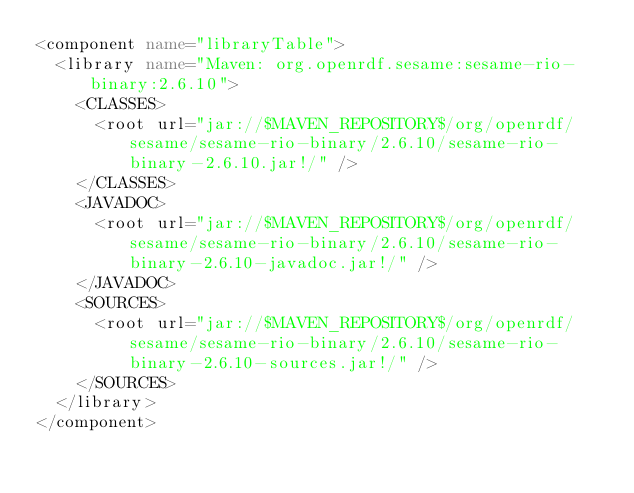Convert code to text. <code><loc_0><loc_0><loc_500><loc_500><_XML_><component name="libraryTable">
  <library name="Maven: org.openrdf.sesame:sesame-rio-binary:2.6.10">
    <CLASSES>
      <root url="jar://$MAVEN_REPOSITORY$/org/openrdf/sesame/sesame-rio-binary/2.6.10/sesame-rio-binary-2.6.10.jar!/" />
    </CLASSES>
    <JAVADOC>
      <root url="jar://$MAVEN_REPOSITORY$/org/openrdf/sesame/sesame-rio-binary/2.6.10/sesame-rio-binary-2.6.10-javadoc.jar!/" />
    </JAVADOC>
    <SOURCES>
      <root url="jar://$MAVEN_REPOSITORY$/org/openrdf/sesame/sesame-rio-binary/2.6.10/sesame-rio-binary-2.6.10-sources.jar!/" />
    </SOURCES>
  </library>
</component></code> 